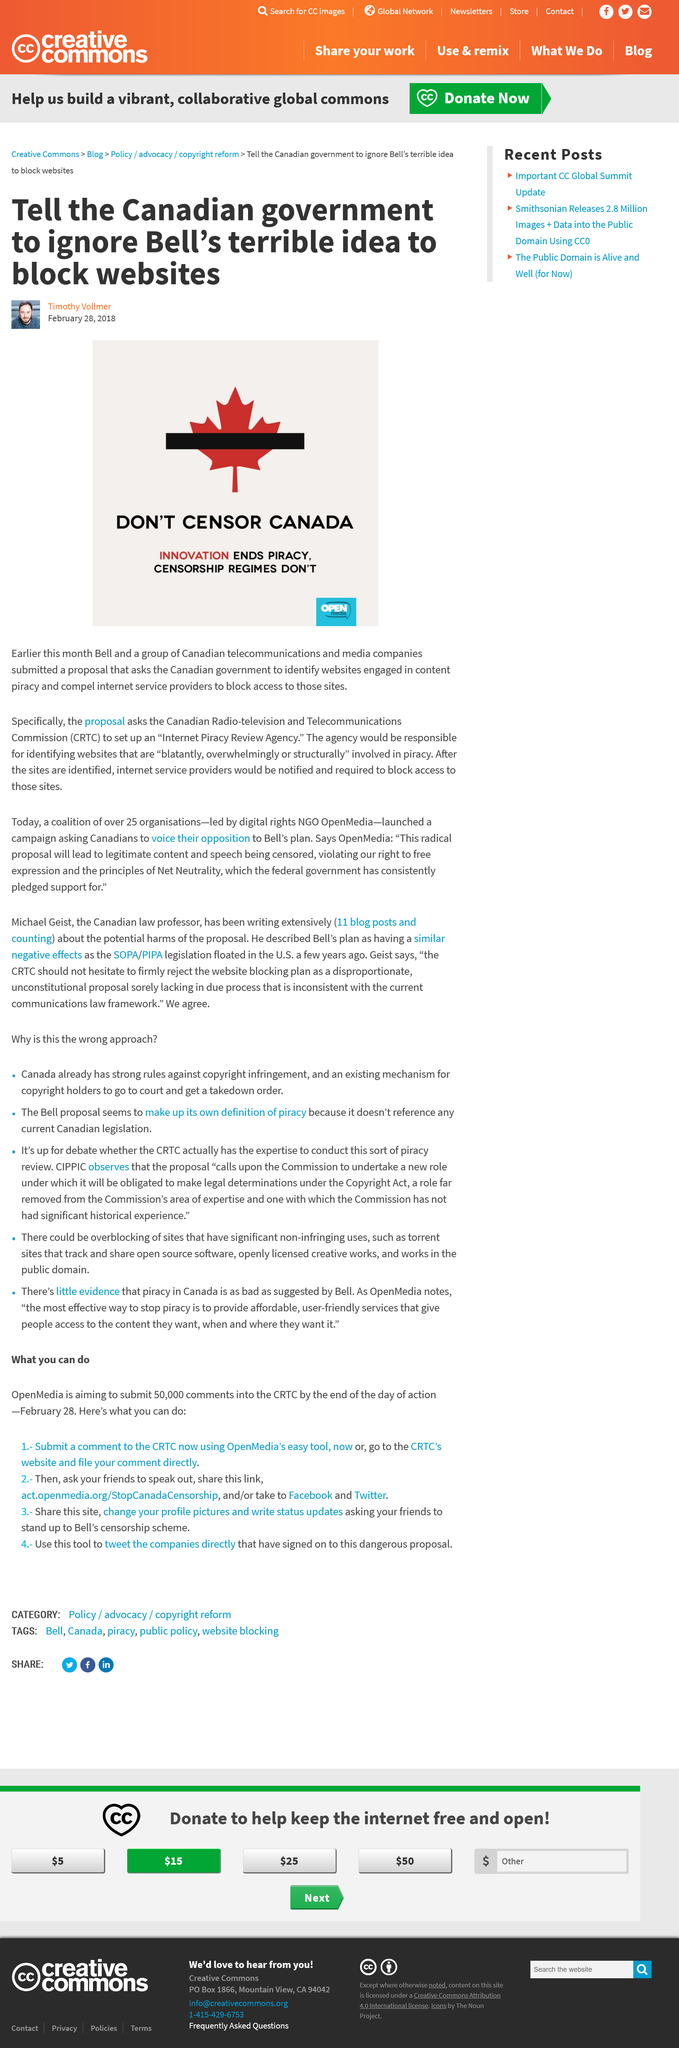Specify some key components in this picture. On March 12, 2023, a group of Canadian telecommunication and media companies, including Bell and Who, submitted a proposal to the CRTC for a wireless merger. In February, Bell submitted their proposal. In the realm of images, innovation is the key to ending piracy. 